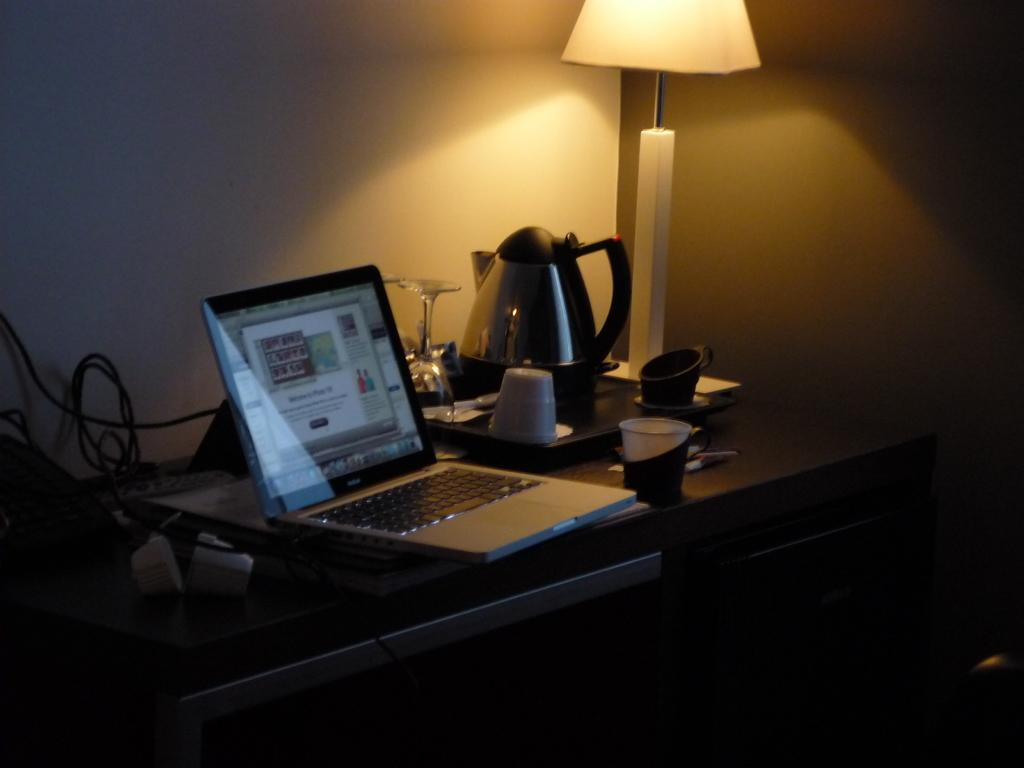What electronic device is visible in the image? There is a laptop in the image. What is another object related to typing or inputting information in the image? There is a keyboard in the image. Can you describe any other objects on the table in the image? There is a wire, books, a cup, a glass, a kettle, and a lamp on the table in the image. How many passengers are shown in the image? There are no passengers present in the image; it features a table with various objects. What type of ticket can be seen in the image? There is no ticket present in the image. 